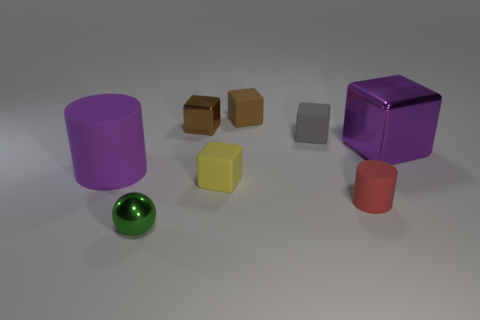Is there anything else that has the same size as the green metallic ball?
Offer a very short reply. Yes. There is a small object that is the same color as the small metallic block; what is it made of?
Your answer should be very brief. Rubber. Is the color of the large rubber object the same as the big shiny object?
Provide a short and direct response. Yes. How many objects are tiny brown objects that are to the right of the yellow rubber cube or shiny objects to the left of the big block?
Your answer should be compact. 3. Are there more green metallic spheres behind the tiny gray thing than small matte objects that are right of the yellow rubber thing?
Provide a short and direct response. No. There is a matte object on the left side of the green object; what is its color?
Offer a terse response. Purple. Is there another metallic object of the same shape as the yellow thing?
Offer a very short reply. Yes. What number of yellow things are tiny rubber cubes or tiny metallic spheres?
Ensure brevity in your answer.  1. Are there any purple rubber cylinders that have the same size as the brown shiny block?
Ensure brevity in your answer.  No. What number of brown rubber blocks are there?
Your answer should be very brief. 1. 